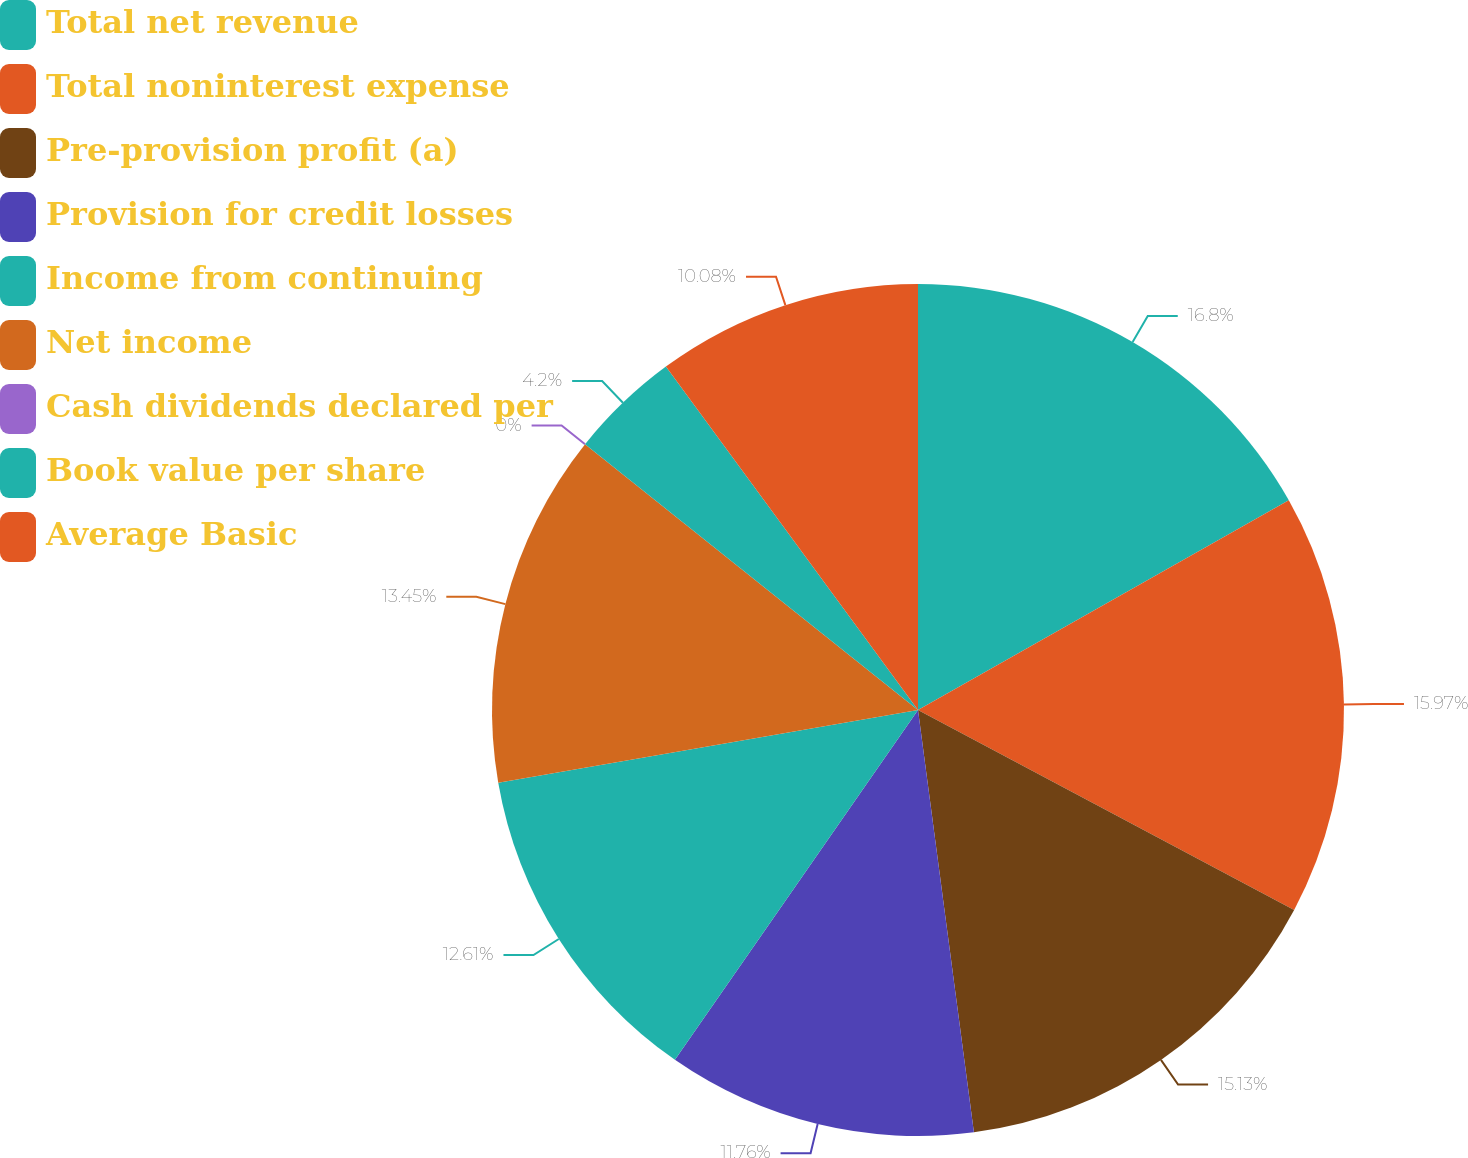Convert chart to OTSL. <chart><loc_0><loc_0><loc_500><loc_500><pie_chart><fcel>Total net revenue<fcel>Total noninterest expense<fcel>Pre-provision profit (a)<fcel>Provision for credit losses<fcel>Income from continuing<fcel>Net income<fcel>Cash dividends declared per<fcel>Book value per share<fcel>Average Basic<nl><fcel>16.81%<fcel>15.97%<fcel>15.13%<fcel>11.76%<fcel>12.61%<fcel>13.45%<fcel>0.0%<fcel>4.2%<fcel>10.08%<nl></chart> 